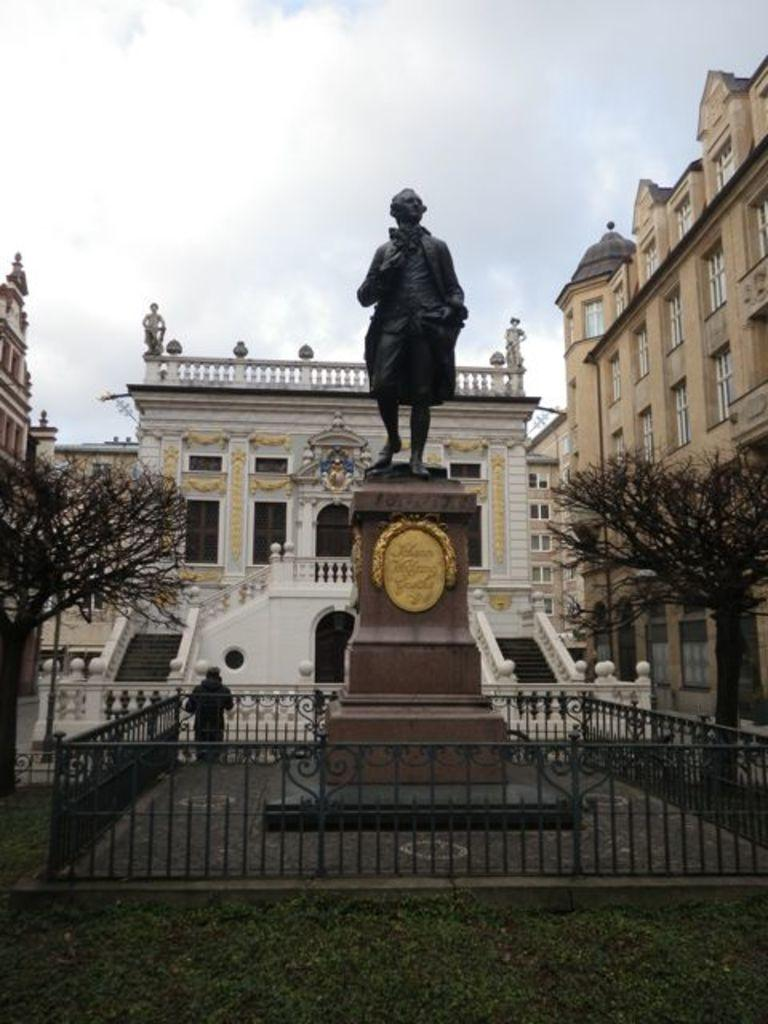What type of barrier can be seen in the image? There is a fence in the image. What is the main object featured in the image? There is a statue in the image. What type of vegetation is present in the image? There is grass in the image. Can you describe the person in the image? There is a person standing in the image. What other natural elements can be seen in the image? There are trees in the image. Are there any architectural features in the image? Yes, there are stairs and a building in the image. What is visible at the top of the image? The sky is visible at the top of the image. How many donkeys are present in the image? There are no donkeys present in the image. What type of trail can be seen in the image? There is no trail visible in the image. 